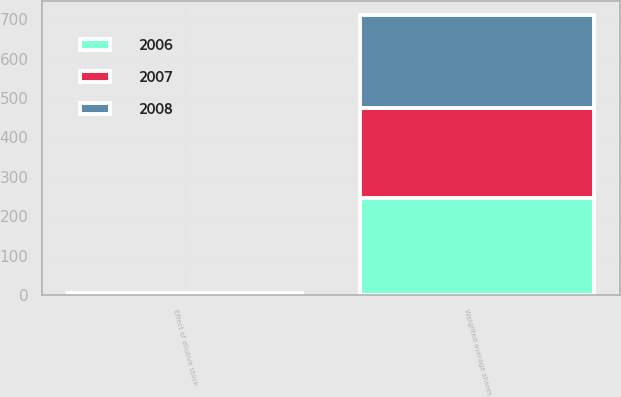Convert chart. <chart><loc_0><loc_0><loc_500><loc_500><stacked_bar_chart><ecel><fcel>Weighted average shares<fcel>Effect of dilutive stock<nl><fcel>2007<fcel>228.3<fcel>1<nl><fcel>2008<fcel>237.5<fcel>2<nl><fcel>2006<fcel>245.4<fcel>2.4<nl></chart> 